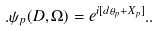Convert formula to latex. <formula><loc_0><loc_0><loc_500><loc_500>. \psi _ { p } ( D , \Omega ) = e ^ { i [ d \theta _ { p } + X _ { p } ] } . .</formula> 